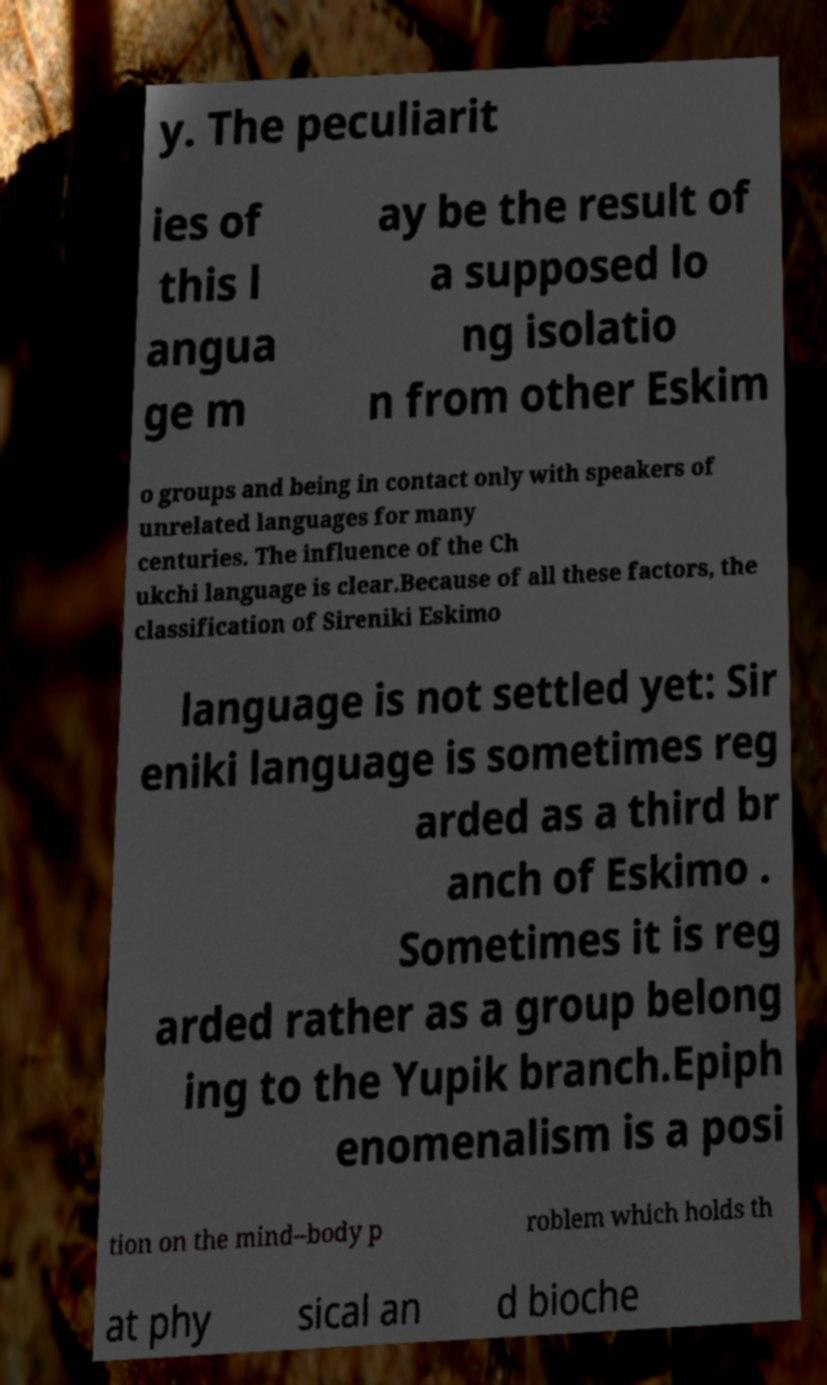For documentation purposes, I need the text within this image transcribed. Could you provide that? y. The peculiarit ies of this l angua ge m ay be the result of a supposed lo ng isolatio n from other Eskim o groups and being in contact only with speakers of unrelated languages for many centuries. The influence of the Ch ukchi language is clear.Because of all these factors, the classification of Sireniki Eskimo language is not settled yet: Sir eniki language is sometimes reg arded as a third br anch of Eskimo . Sometimes it is reg arded rather as a group belong ing to the Yupik branch.Epiph enomenalism is a posi tion on the mind–body p roblem which holds th at phy sical an d bioche 